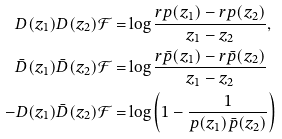Convert formula to latex. <formula><loc_0><loc_0><loc_500><loc_500>D ( z _ { 1 } ) D ( z _ { 2 } ) { \mathcal { F } } = & \log \frac { r p ( z _ { 1 } ) - r p ( z _ { 2 } ) } { z _ { 1 } - z _ { 2 } } , \\ \bar { D } ( z _ { 1 } ) \bar { D } ( z _ { 2 } ) { \mathcal { F } } = & \log \frac { r \bar { p } ( z _ { 1 } ) - r \bar { p } ( z _ { 2 } ) } { z _ { 1 } - z _ { 2 } } \\ - D ( z _ { 1 } ) \bar { D } ( z _ { 2 } ) \mathcal { F } = & \log \left ( 1 - \frac { 1 } { p ( z _ { 1 } ) \bar { p } ( z _ { 2 } ) } \right )</formula> 